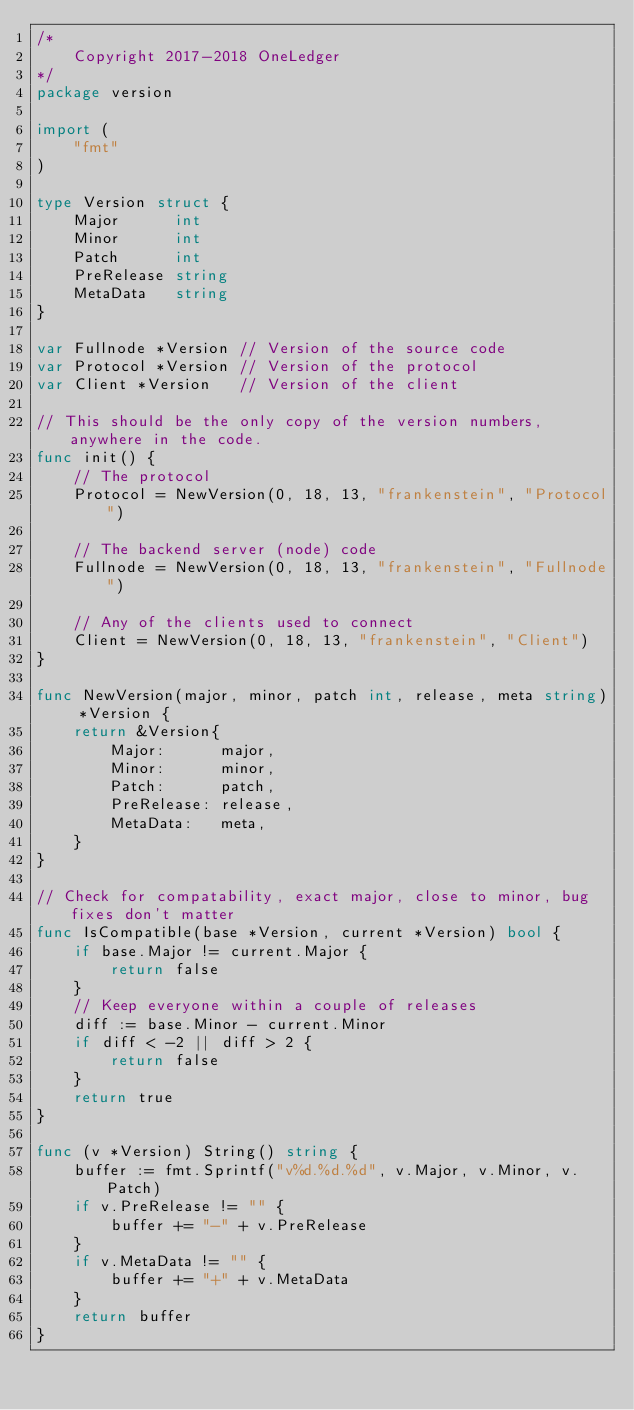<code> <loc_0><loc_0><loc_500><loc_500><_Go_>/*
	Copyright 2017-2018 OneLedger
*/
package version

import (
	"fmt"
)

type Version struct {
	Major      int
	Minor      int
	Patch      int
	PreRelease string
	MetaData   string
}

var Fullnode *Version // Version of the source code
var Protocol *Version // Version of the protocol
var Client *Version   // Version of the client

// This should be the only copy of the version numbers, anywhere in the code.
func init() {
	// The protocol
	Protocol = NewVersion(0, 18, 13, "frankenstein", "Protocol")

	// The backend server (node) code
	Fullnode = NewVersion(0, 18, 13, "frankenstein", "Fullnode")

	// Any of the clients used to connect
	Client = NewVersion(0, 18, 13, "frankenstein", "Client")
}

func NewVersion(major, minor, patch int, release, meta string) *Version {
	return &Version{
		Major:      major,
		Minor:      minor,
		Patch:      patch,
		PreRelease: release,
		MetaData:   meta,
	}
}

// Check for compatability, exact major, close to minor, bug fixes don't matter
func IsCompatible(base *Version, current *Version) bool {
	if base.Major != current.Major {
		return false
	}
	// Keep everyone within a couple of releases
	diff := base.Minor - current.Minor
	if diff < -2 || diff > 2 {
		return false
	}
	return true
}

func (v *Version) String() string {
	buffer := fmt.Sprintf("v%d.%d.%d", v.Major, v.Minor, v.Patch)
	if v.PreRelease != "" {
		buffer += "-" + v.PreRelease
	}
	if v.MetaData != "" {
		buffer += "+" + v.MetaData
	}
	return buffer
}
</code> 